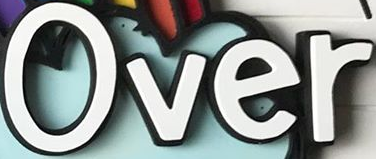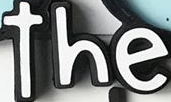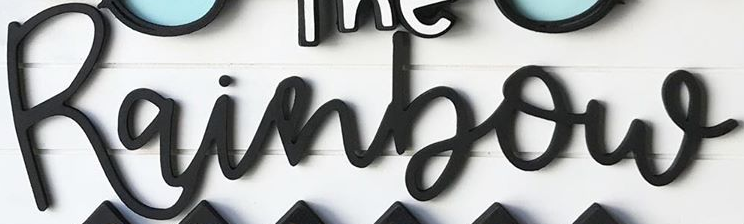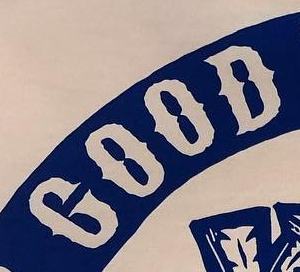What words can you see in these images in sequence, separated by a semicolon? Over; the; Rainbow; GOOD 